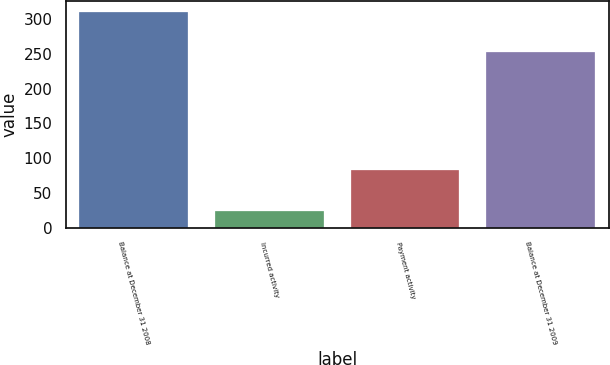Convert chart. <chart><loc_0><loc_0><loc_500><loc_500><bar_chart><fcel>Balance at December 31 2008<fcel>Incurred activity<fcel>Payment activity<fcel>Balance at December 31 2009<nl><fcel>310<fcel>24<fcel>83<fcel>252<nl></chart> 